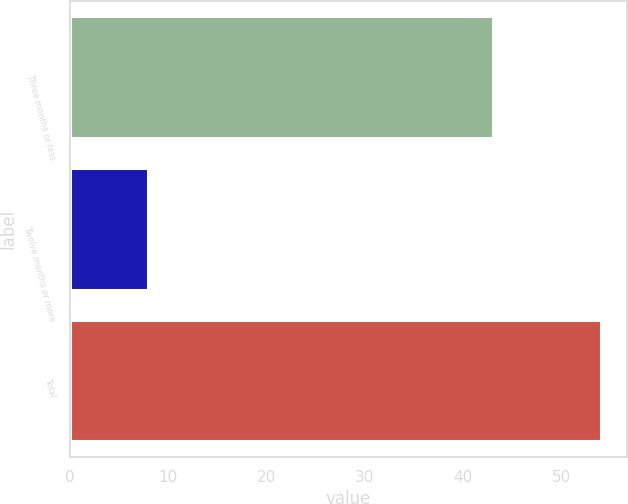Convert chart. <chart><loc_0><loc_0><loc_500><loc_500><bar_chart><fcel>Three months or less<fcel>Twelve months or more<fcel>Total<nl><fcel>43<fcel>8<fcel>54<nl></chart> 